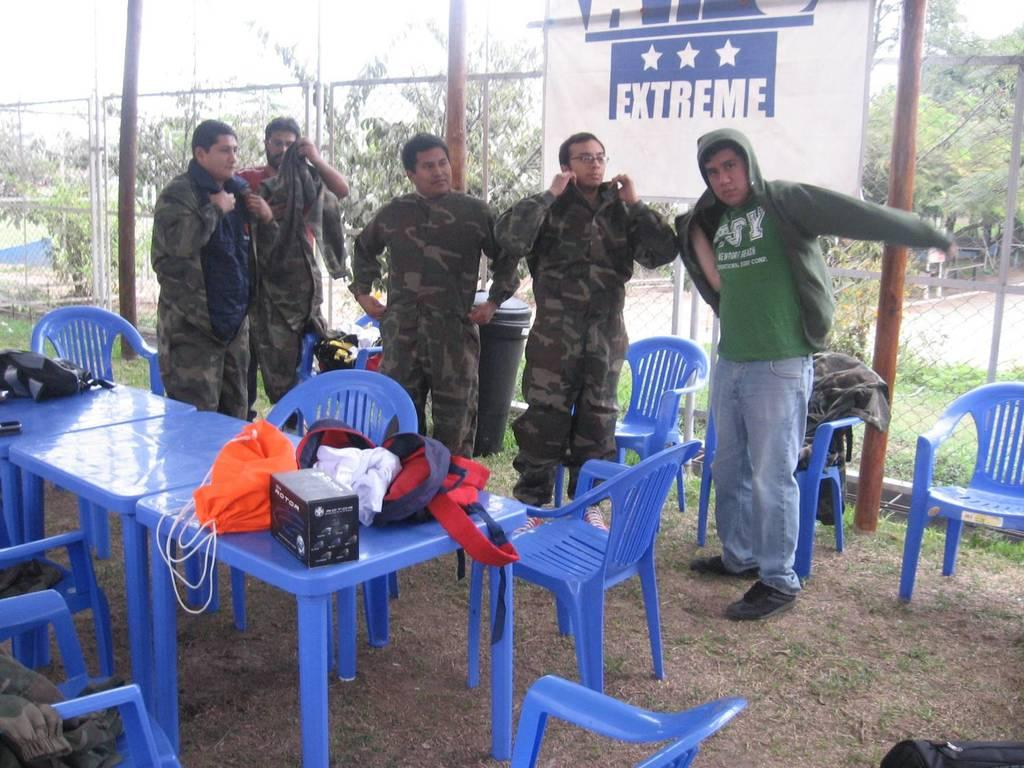How many people are present in the image? There are five people standing in the image. What type of furniture is visible in the image? There is a table and a chair in the image. What objects are on the table? There is a bag and a box on the table. What can be seen in the background of the image? There is a small plant and fencing in the background of the image. What type of roof can be seen in the image? There is no roof visible in the image. What type of trade is being conducted in the image? There is no trade being conducted in the image; it is a scene with people, furniture, and objects. 